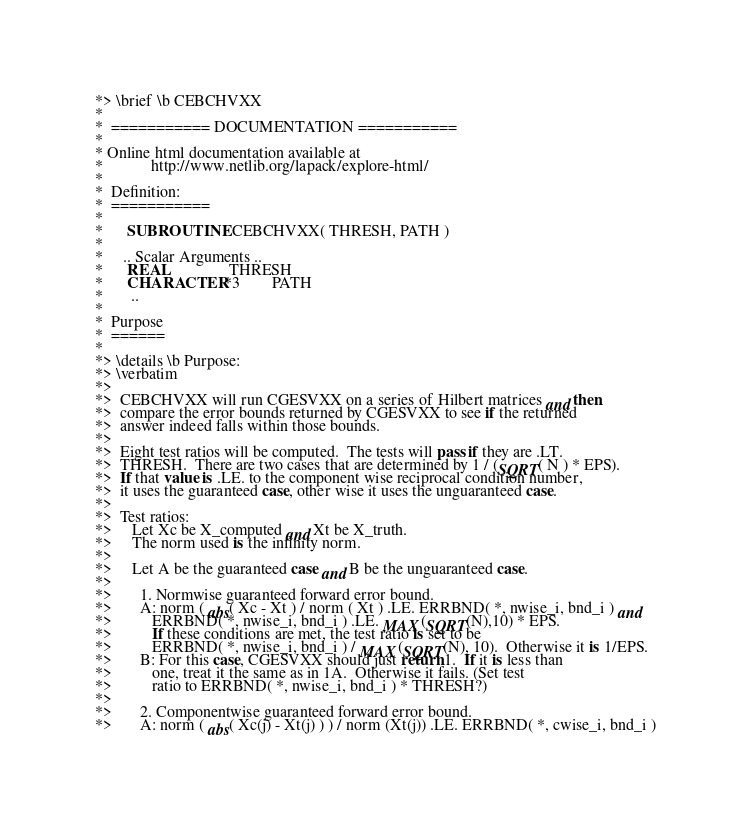<code> <loc_0><loc_0><loc_500><loc_500><_FORTRAN_>*> \brief \b CEBCHVXX
*
*  =========== DOCUMENTATION ===========
*
* Online html documentation available at 
*            http://www.netlib.org/lapack/explore-html/ 
*
*  Definition:
*  ===========
*
*      SUBROUTINE CEBCHVXX( THRESH, PATH )
*
*     .. Scalar Arguments ..
*      REAL               THRESH
*      CHARACTER*3        PATH
*       ..
*
*  Purpose
*  ======
*
*> \details \b Purpose:
*> \verbatim
*>
*>  CEBCHVXX will run CGESVXX on a series of Hilbert matrices and then
*>  compare the error bounds returned by CGESVXX to see if the returned
*>  answer indeed falls within those bounds.
*>
*>  Eight test ratios will be computed.  The tests will pass if they are .LT.
*>  THRESH.  There are two cases that are determined by 1 / (SQRT( N ) * EPS).
*>  If that value is .LE. to the component wise reciprocal condition number,
*>  it uses the guaranteed case, other wise it uses the unguaranteed case.
*>
*>  Test ratios:
*>     Let Xc be X_computed and Xt be X_truth.
*>     The norm used is the infinity norm.
*>
*>     Let A be the guaranteed case and B be the unguaranteed case.
*>
*>       1. Normwise guaranteed forward error bound.
*>       A: norm ( abs( Xc - Xt ) / norm ( Xt ) .LE. ERRBND( *, nwise_i, bnd_i ) and
*>          ERRBND( *, nwise_i, bnd_i ) .LE. MAX(SQRT(N),10) * EPS.
*>          If these conditions are met, the test ratio is set to be
*>          ERRBND( *, nwise_i, bnd_i ) / MAX(SQRT(N), 10).  Otherwise it is 1/EPS.
*>       B: For this case, CGESVXX should just return 1.  If it is less than
*>          one, treat it the same as in 1A.  Otherwise it fails. (Set test
*>          ratio to ERRBND( *, nwise_i, bnd_i ) * THRESH?)
*>
*>       2. Componentwise guaranteed forward error bound.
*>       A: norm ( abs( Xc(j) - Xt(j) ) ) / norm (Xt(j)) .LE. ERRBND( *, cwise_i, bnd_i )</code> 